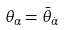Convert formula to latex. <formula><loc_0><loc_0><loc_500><loc_500>\theta _ { \alpha } = \bar { \theta } _ { \dot { \alpha } }</formula> 